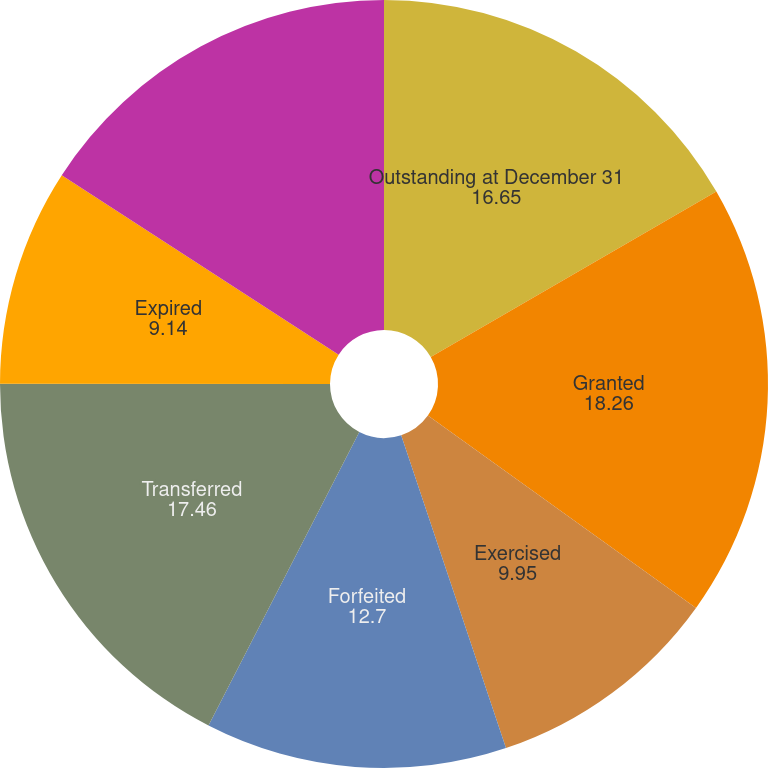Convert chart to OTSL. <chart><loc_0><loc_0><loc_500><loc_500><pie_chart><fcel>Outstanding at December 31<fcel>Granted<fcel>Exercised<fcel>Forfeited<fcel>Transferred<fcel>Expired<fcel>Vested and expected to vest at<nl><fcel>16.65%<fcel>18.26%<fcel>9.95%<fcel>12.7%<fcel>17.46%<fcel>9.14%<fcel>15.85%<nl></chart> 